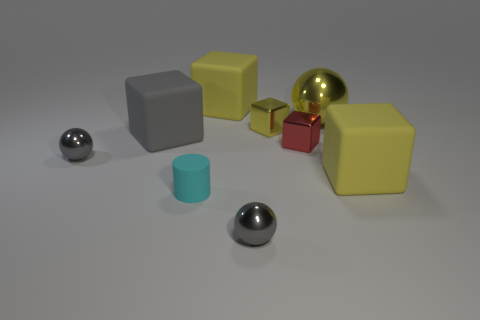Are there any rubber blocks that have the same color as the large metal ball?
Provide a short and direct response. Yes. There is a small metallic object that is the same color as the big metallic sphere; what is its shape?
Provide a short and direct response. Cube. What shape is the gray object that is the same material as the cylinder?
Keep it short and to the point. Cube. There is a shiny ball to the left of the big yellow matte thing that is behind the red cube; what is its size?
Offer a very short reply. Small. What number of things are either tiny gray things that are to the right of the tiny cylinder or big matte things behind the yellow shiny block?
Make the answer very short. 2. Are there fewer gray metal objects than blocks?
Provide a succinct answer. Yes. What number of things are tiny gray metal things or purple matte things?
Make the answer very short. 2. Does the small cyan rubber thing have the same shape as the small yellow shiny object?
Give a very brief answer. No. Is the size of the yellow matte object to the right of the red metal cube the same as the thing behind the big metallic thing?
Provide a succinct answer. Yes. What is the material of the thing that is both behind the small red object and to the left of the cyan cylinder?
Give a very brief answer. Rubber. 